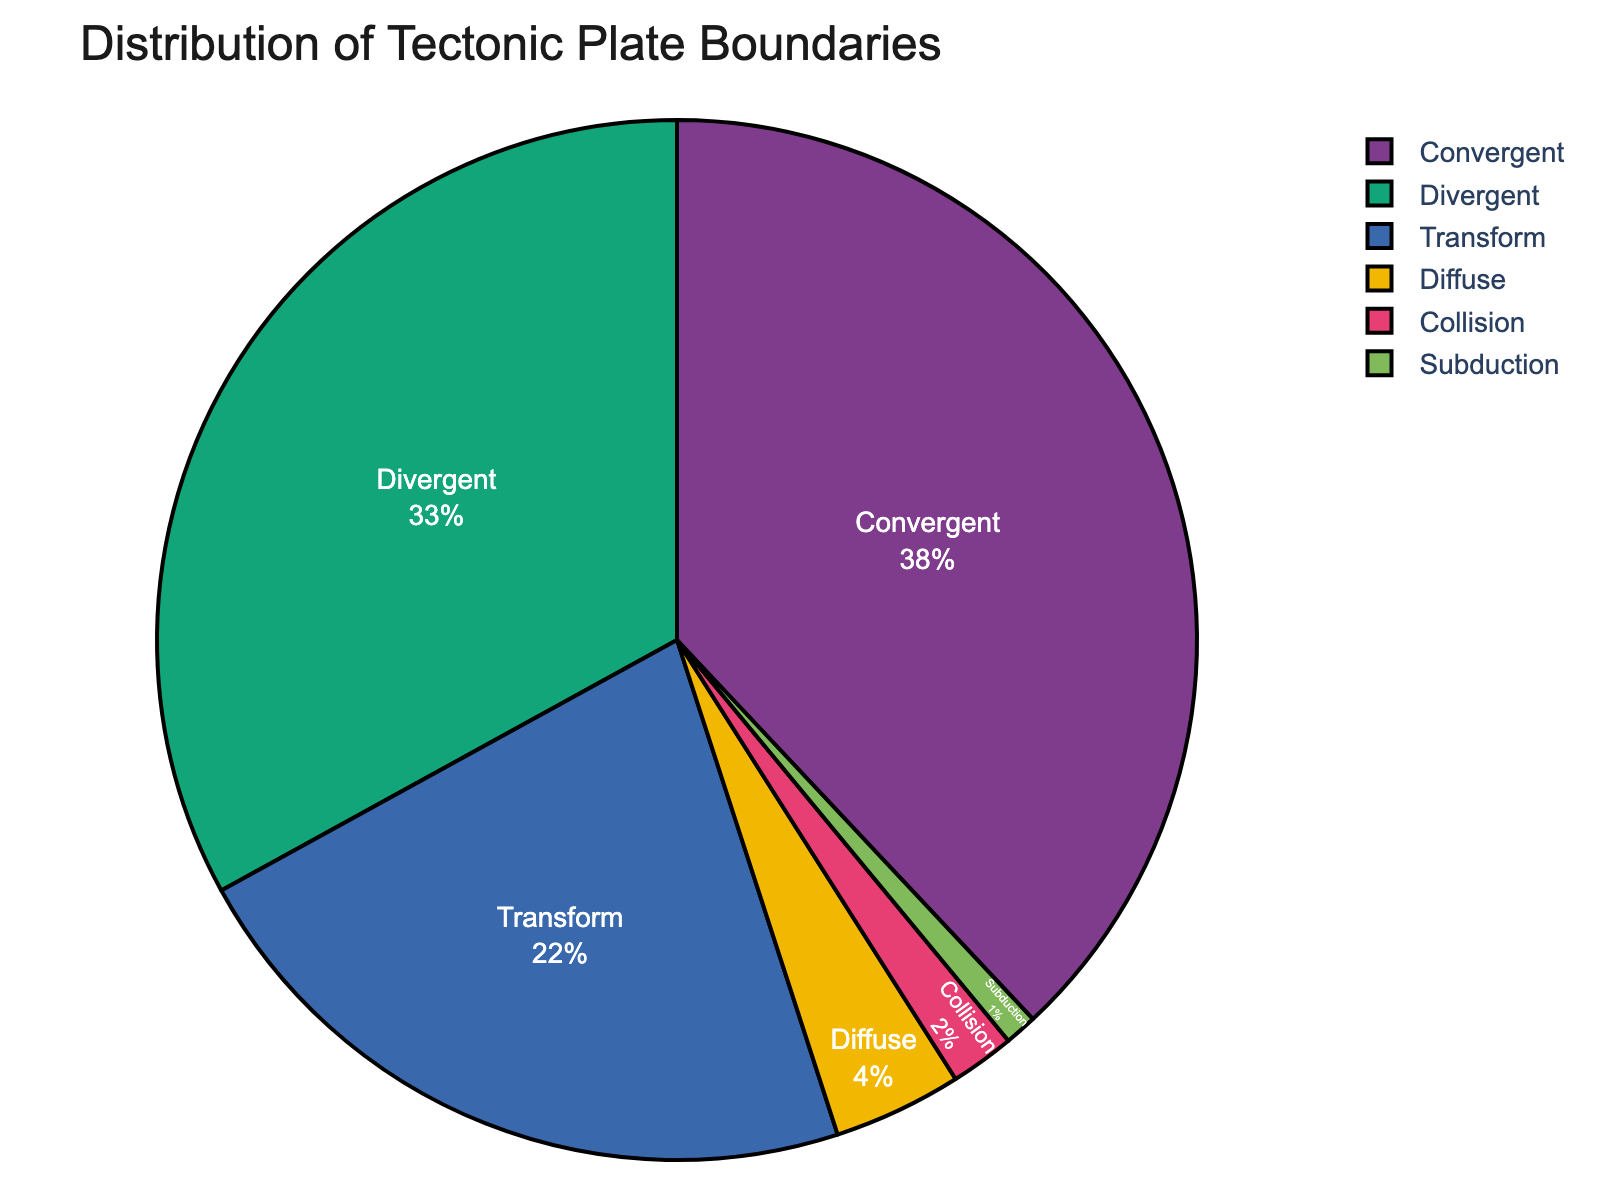What is the most common type of tectonic plate boundary worldwide? The pie chart shows the distribution percentages of different tectonic plate boundaries. The largest section is marked "Convergent" with 38%.
Answer: Convergent What is the combined percentage of Convergent and Divergent plate boundaries? The percentage of Convergent boundaries is 38% and Divergent is 33%. Adding these together gives 38 + 33 = 71%.
Answer: 71% Which boundary type is more common, Transform or Diffuse? The pie chart shows Transform boundaries at 22% and Diffuse boundaries at 4%. Since 22% is greater than 4%, Transform is more common.
Answer: Transform How many times more common are Convergent boundaries compared to Collision boundaries? Convergent boundaries are at 38% and Collision boundaries are at 2%. To find how many times more common, divide 38 by 2, which equals 19.
Answer: 19 times Which boundary type occupies the smallest section of the pie chart, and what is its percentage? By examining the pie chart, the smallest section is labeled "Subduction" with a percentage of 1%.
Answer: Subduction, 1% What is the difference in percentage between Divergent and Transform boundaries? The percentage of Divergent boundaries is 33% while Transform boundaries are 22%. Subtracting these gives 33 - 22 = 11%.
Answer: 11% Are Convergent boundaries more common than the sum of Collision and Subduction boundaries? Convergent boundaries are 38%. Collision boundaries are 2% and Subduction boundaries are 1%. The sum of Collision and Subduction boundaries is 2 + 1 = 3%. Since 38% is greater than 3%, Convergent boundaries are more common.
Answer: Yes What color represents the Divergent boundaries in the pie chart? By looking at the pie chart, we identify the color associated with the label "Divergent". The specific color assigned by the chart is visually evident.
Answer: Answer based on actual chart observation (e.g., Blue) Which boundary type has roughly a third of the total distribution? The pie chart shows percentages for different boundary types. The label with approximately 33% is "Divergent".
Answer: Divergent 